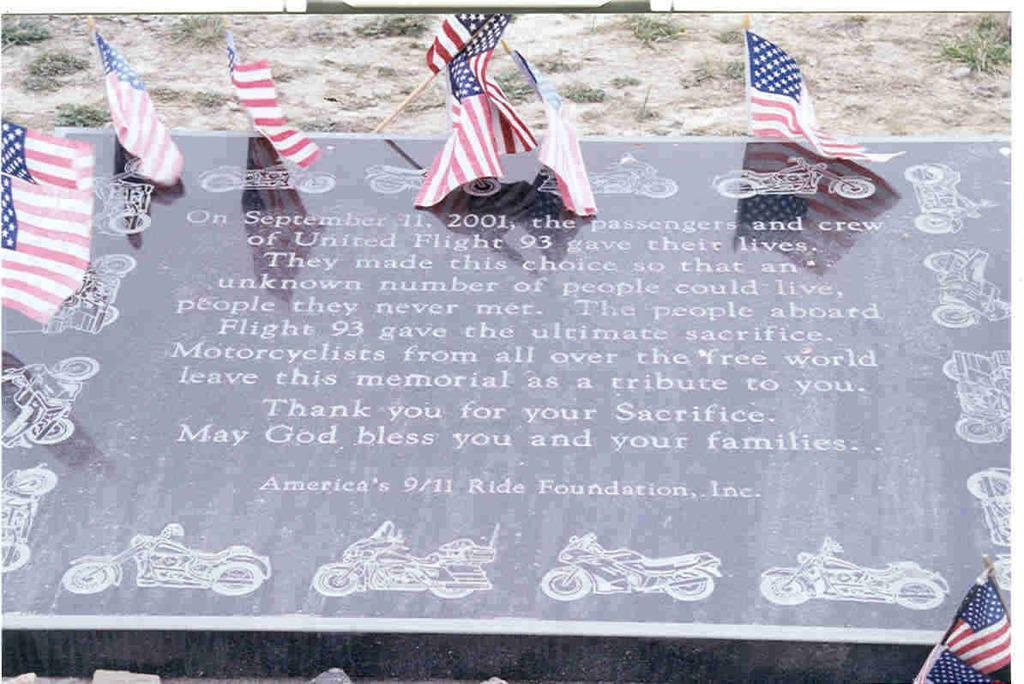What is the main subject of the picture? The main subject of the picture is a memorial headstone. Can you describe the headstone? The headstone has text on it. What else can be seen in the picture? There are flags in the top of the picture. What type of calculator is being used by the person in the picture? There is no person or calculator present in the image; it features a memorial headstone and flags. Can you describe the haircut of the person in the picture? There is no person present in the image, so it is not possible to describe their haircut. 